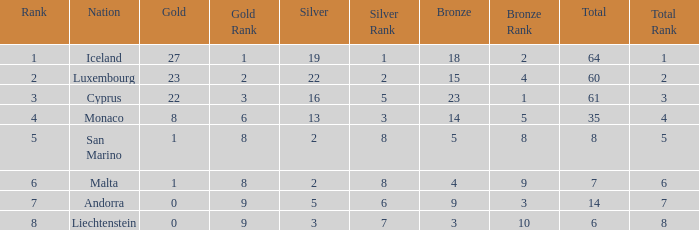How many bronzes for Iceland with over 2 silvers? 18.0. 